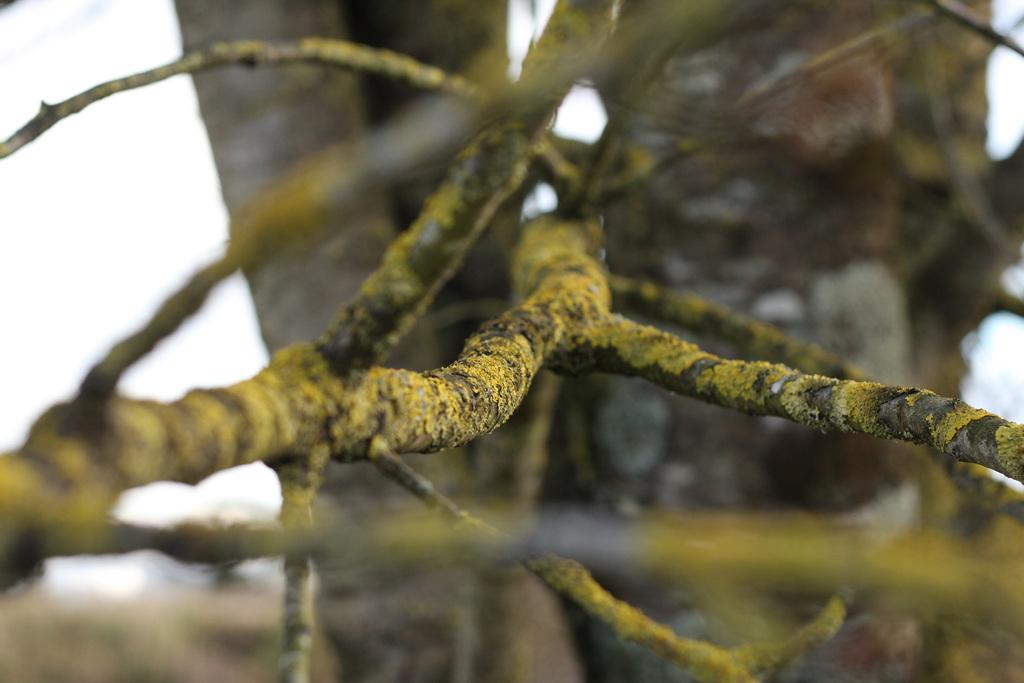What type of vegetation can be seen in the image? There are tree branches with algae in the image. What else can be seen in the background of the image besides the sky? Tree trunks are visible in the background of the image. What is visible at the top of the image? The sky is visible in the background of the image. What is the tax rate for the ducks in the image? There are no ducks present in the image, and therefore no tax rate can be determined. 